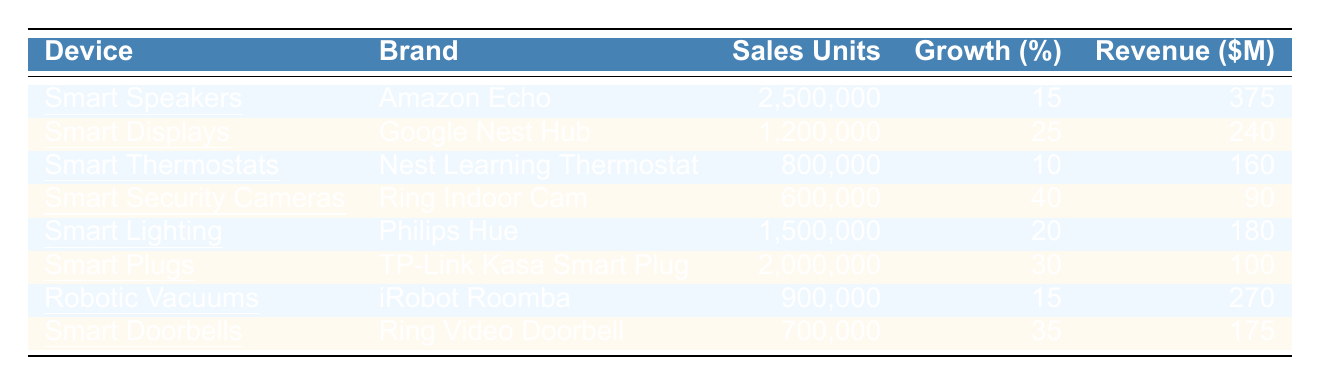What is the total sales units for Smart Speakers? The sales units for Smart Speakers, specifically Amazon Echo, is directly provided in the table as 2,500,000.
Answer: 2,500,000 Which device had the highest growth percentage in sales? By looking at the growth percentages listed in the table, Smart Security Cameras (Ring Indoor Cam) show the highest growth at 40%.
Answer: Smart Security Cameras What is the total revenue generated from Smart Plugs? The revenue for Smart Plugs, which are TP-Link Kasa Smart Plugs, is explicitly mentioned in the table as 100 million dollars.
Answer: 100 million How many sales units were there for Robotic Vacuums? The table specifies that the sales units for Robotic Vacuums (iRobot Roomba) is 900,000.
Answer: 900,000 What is the average growth percentage for all smart home devices? To find the average growth percentage, sum all growth percentages (15 + 25 + 10 + 40 + 20 + 30 + 15 + 35 = 250) and divide by the number of devices (8): 250/8 = 31.25%.
Answer: 31.25% Did Smart Displays generate more or less revenue than Smart Lighting? The revenue for Smart Displays (240 million) is compared with Smart Lighting (180 million). Since 240 > 180, it generated more revenue.
Answer: More How many more sales units did Smart Speakers have compared to Smart Doorbells? Smart Speakers had 2,500,000 units, while Smart Doorbells had 700,000 units. The difference is 2,500,000 - 700,000 = 1,800,000 sales units.
Answer: 1,800,000 What is the total revenue generated by all devices combined? The total revenue is found by adding the revenues of all devices (375 + 240 + 160 + 90 + 180 + 100 + 270 + 175 = 1610 million dollars).
Answer: 1610 million Which device had the least sales units? Looking through the sales units provided, Smart Security Cameras had the least sales units with 600,000.
Answer: Smart Security Cameras What percentage of total sales units does Smart Lighting represent? The total sales units are 2,500,000 + 1,200,000 + 800,000 + 600,000 + 1,500,000 + 2,000,000 + 900,000 + 700,000 = 10,300,000. Smart Lighting had 1,500,000 units, making its percentage (1,500,000 / 10,300,000) * 100 ≈ 14.56%.
Answer: ≈ 14.56% 